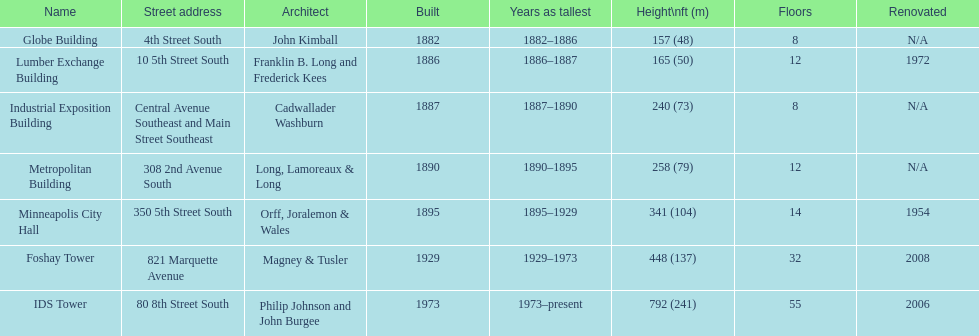Between the metropolitan building and the lumber exchange building, which one has a greater height? Metropolitan Building. 